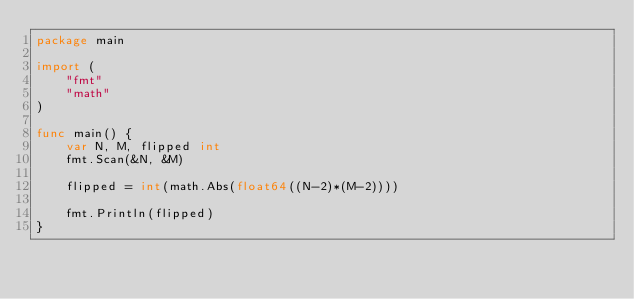Convert code to text. <code><loc_0><loc_0><loc_500><loc_500><_Go_>package main

import (
    "fmt"
    "math"
)

func main() {
    var N, M, flipped int
    fmt.Scan(&N, &M)

    flipped = int(math.Abs(float64((N-2)*(M-2))))
    
    fmt.Println(flipped)
}</code> 